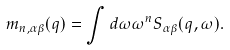<formula> <loc_0><loc_0><loc_500><loc_500>m _ { n , \alpha \beta } ( q ) = \int d \omega \omega ^ { n } S _ { \alpha \beta } ( q , \omega ) .</formula> 